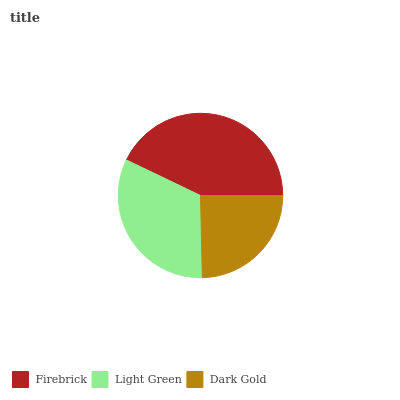Is Dark Gold the minimum?
Answer yes or no. Yes. Is Firebrick the maximum?
Answer yes or no. Yes. Is Light Green the minimum?
Answer yes or no. No. Is Light Green the maximum?
Answer yes or no. No. Is Firebrick greater than Light Green?
Answer yes or no. Yes. Is Light Green less than Firebrick?
Answer yes or no. Yes. Is Light Green greater than Firebrick?
Answer yes or no. No. Is Firebrick less than Light Green?
Answer yes or no. No. Is Light Green the high median?
Answer yes or no. Yes. Is Light Green the low median?
Answer yes or no. Yes. Is Dark Gold the high median?
Answer yes or no. No. Is Firebrick the low median?
Answer yes or no. No. 